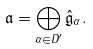Convert formula to latex. <formula><loc_0><loc_0><loc_500><loc_500>\mathfrak { a } = \bigoplus _ { \alpha \in D ^ { \prime } } \hat { \mathfrak { g } } _ { \alpha } .</formula> 